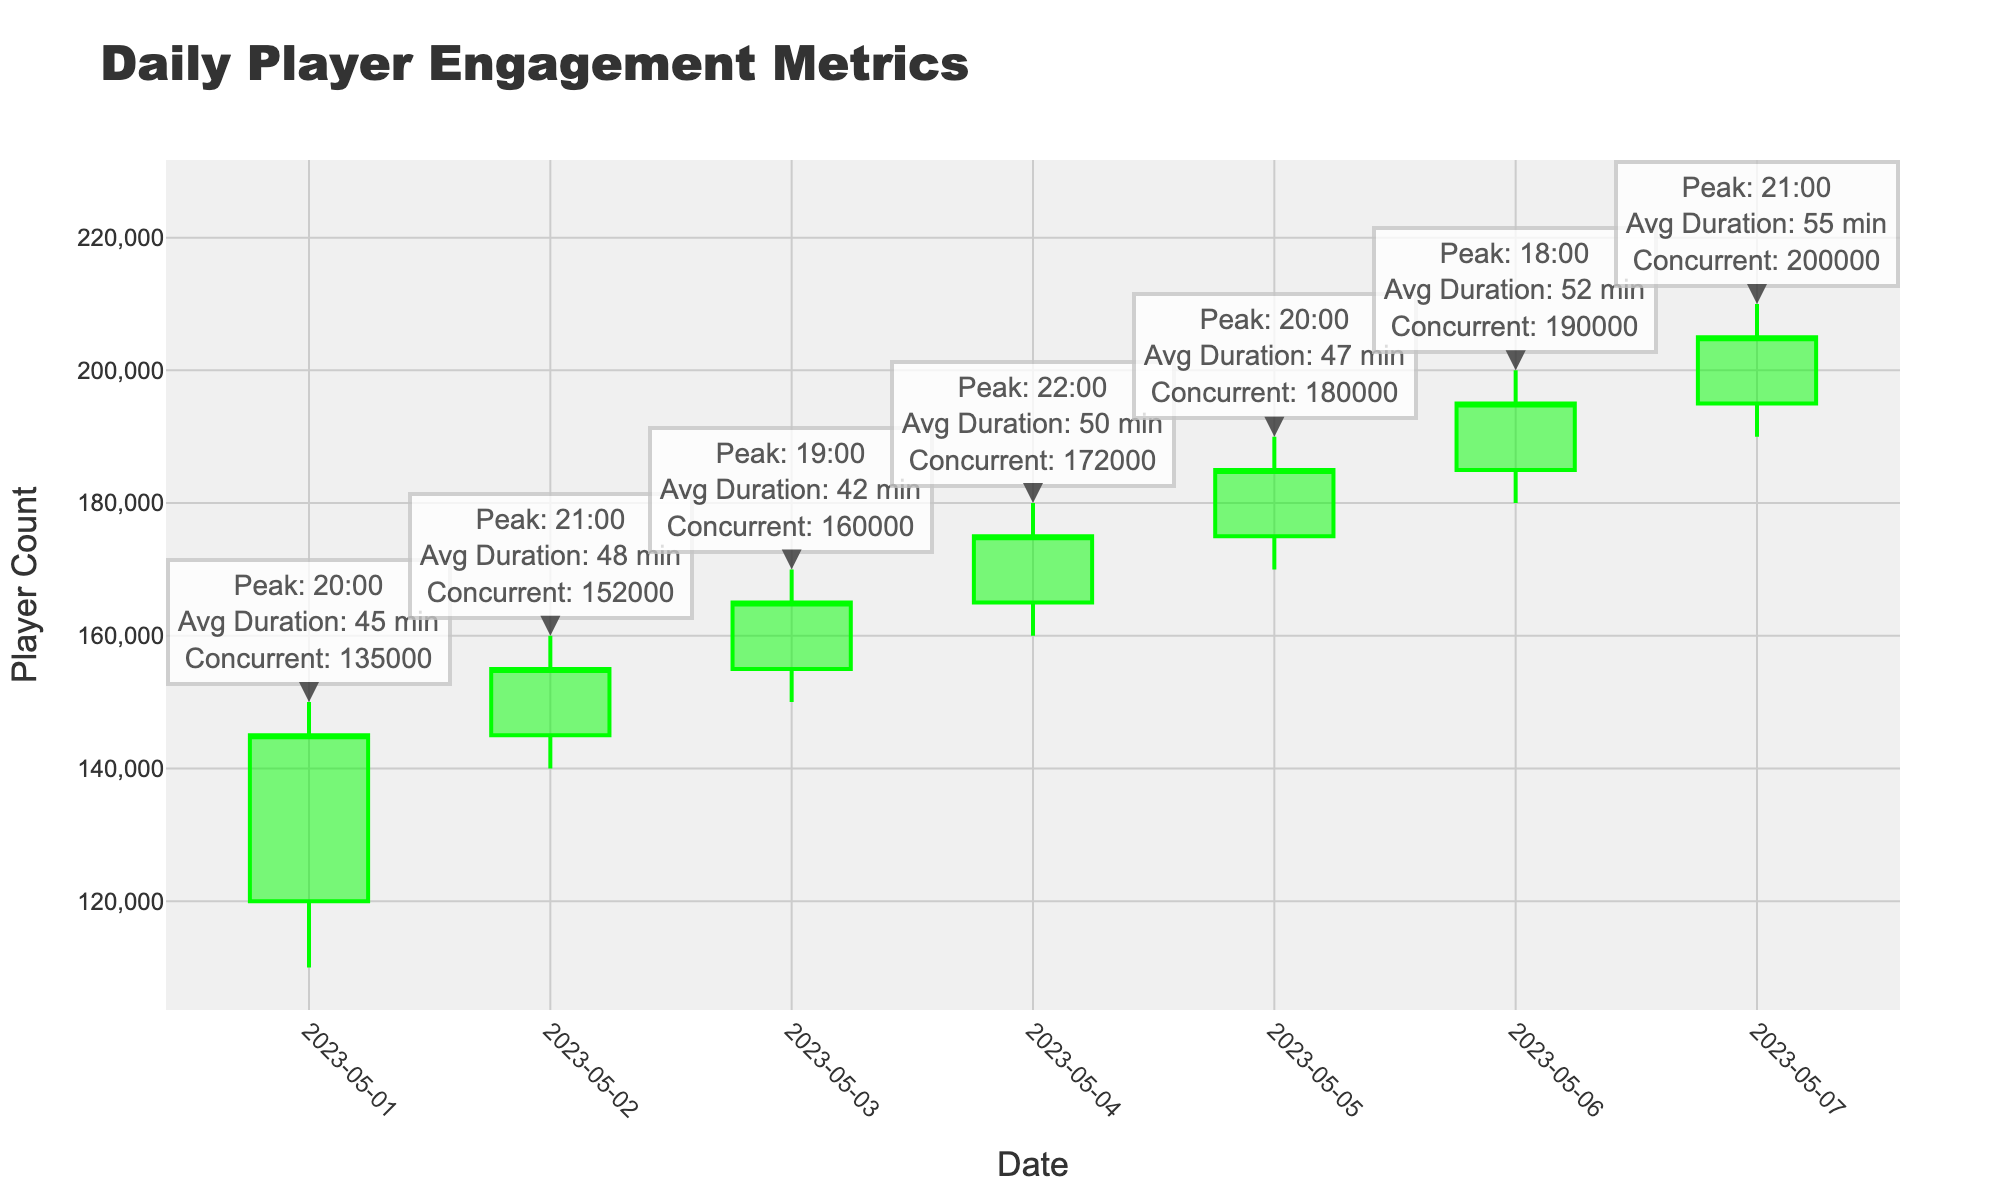What is the highest number of concurrent users recorded on a single day? By looking at the annotations on each day, the highest value is visible where it states "Concurrent: 200000" on 2023-05-07.
Answer: 200000 What is the average session duration on May 3rd? We can find the annotation for May 3rd and see that it states "Avg Duration: 42 min".
Answer: 42 minutes Which day had the highest open value, and what was it? Scan the figure for the tallest opening candlestick bar, which happens to be on 2023-05-07, with an opening value labeled as 195000.
Answer: 2023-05-07, 195000 Was there any day where the player count closed lower than it opened? By comparing the open and close values of each candlestick, we see 2023-05-01 (Open = 120000, Close = 145000) where the value increased, so none.
Answer: None How many days had a peak hour at 20:00? Check the annotations for each day to find "Peak: 20:00". This appears on 2023-05-01 and 2023-05-05, counting them gives us 2 days.
Answer: 2 days Which day had the lowest average session duration and what was it? Looking at the annotations for each day, the lowest average session duration is found on 2023-05-03 with "Avg Duration: 42 min".
Answer: 2023-05-03, 42 minutes What is the sum of the peak hours of engagement for May 2nd and May 6th? From the annotations, May 2nd had a peak hour of 21:00, and May 6th had a peak hour of 18:00. Adding these values (21:00 + 18:00) summed as 39:00.
Answer: 39:00 Is the closing value on May 4th higher or lower compared to May 5th? Compare the closing values on May 4th (175000) and May 5th (185000); since 175000 < 185000, it's lower.
Answer: Lower What was the highest peak player engagement hour across all days? Scan through each annotation to find the highest peak hour, which is visible as 22:00 on 2023-05-04.
Answer: 22:00 Which two consecutive days show the greatest increase in the number of concurrent users? Comparing each consecutive day, the increase from 2023-05-06 (190000) to 2023-05-07 (200000) shows the highest rise of 10000 users.
Answer: 2023-05-06 to 2023-05-07 